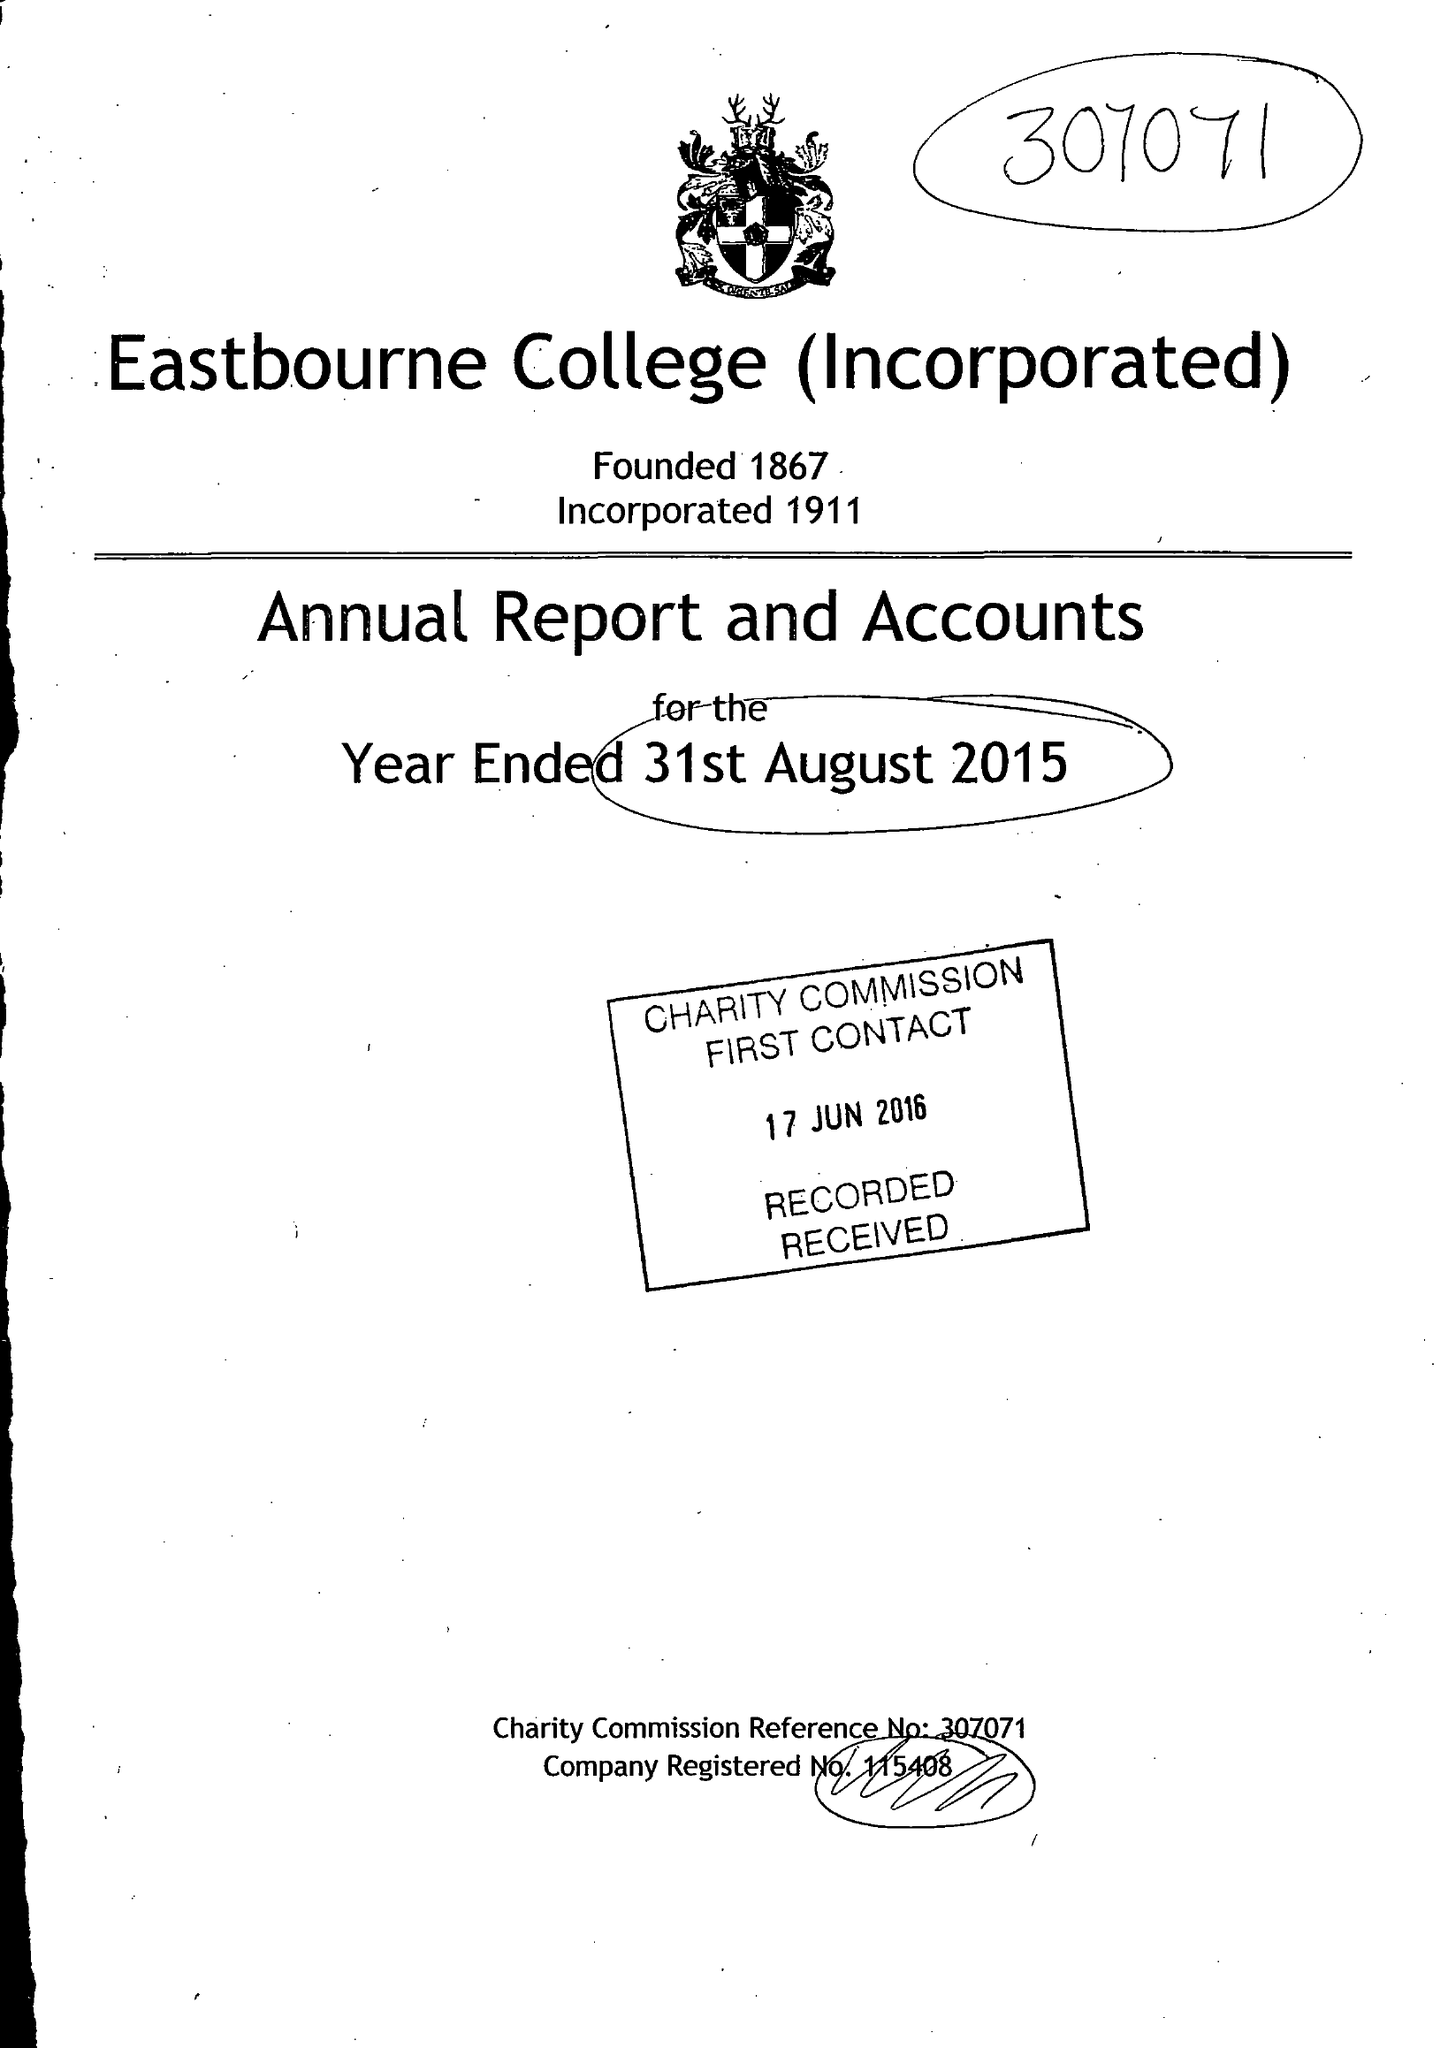What is the value for the income_annually_in_british_pounds?
Answer the question using a single word or phrase. 21327000.00 